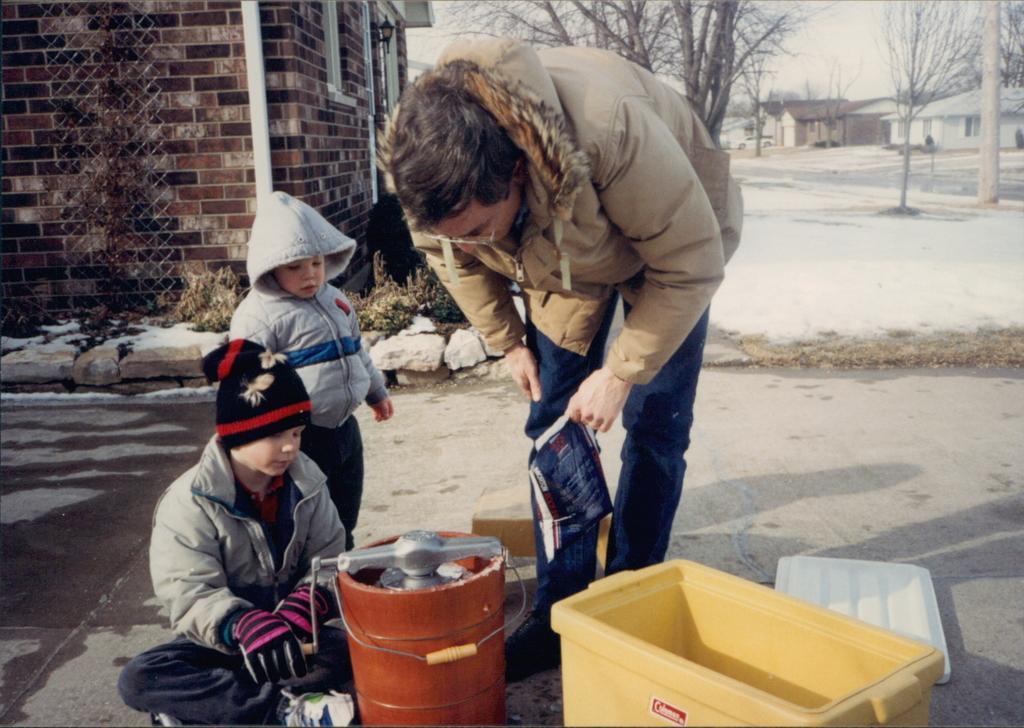Can you describe this image briefly? In this picture there is a man and two small boys in the center of the image, it seems to be a cylinder and a tub at the bottom side of the image and there are houses, trees, a car, and snow in the background area of the image. 